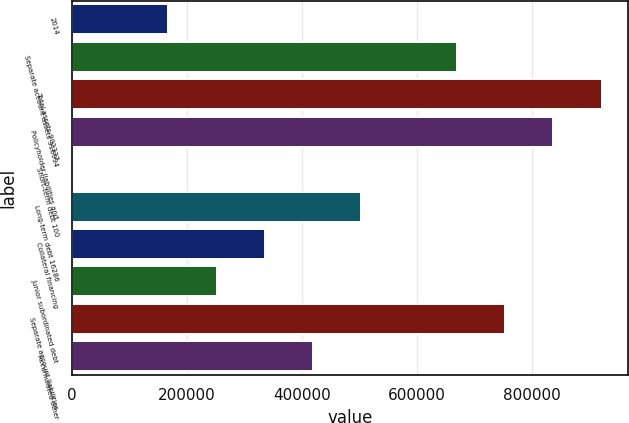<chart> <loc_0><loc_0><loc_500><loc_500><bar_chart><fcel>2014<fcel>Separate account assets 316994<fcel>Total assets 902337<fcel>Policyholder liabilities and<fcel>Short-term debt 100<fcel>Long-term debt 16286<fcel>Collateral financing<fcel>Junior subordinated debt<fcel>Separate account liabilities<fcel>Accumulated other<nl><fcel>167436<fcel>669445<fcel>920449<fcel>836781<fcel>100<fcel>502109<fcel>334772<fcel>251104<fcel>753113<fcel>418440<nl></chart> 